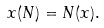<formula> <loc_0><loc_0><loc_500><loc_500>x ( N ) = N ( x ) .</formula> 